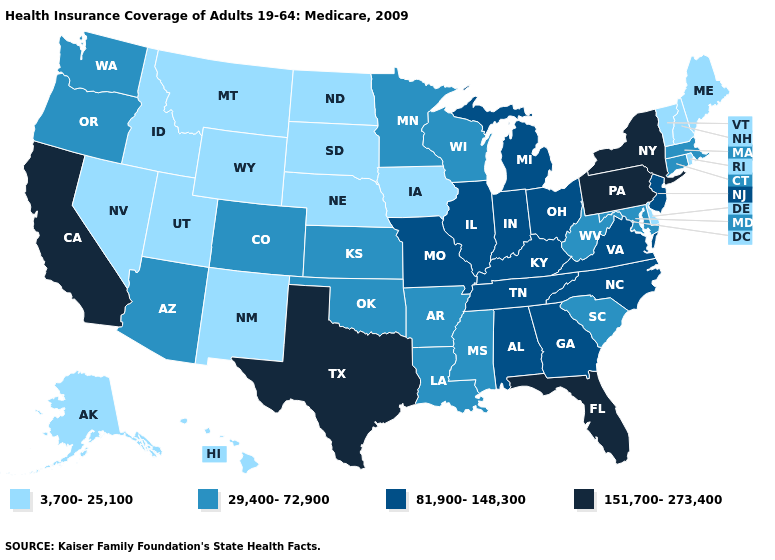Does Washington have the same value as Oklahoma?
Concise answer only. Yes. Does California have the lowest value in the USA?
Keep it brief. No. What is the value of Kansas?
Concise answer only. 29,400-72,900. Which states have the lowest value in the West?
Be succinct. Alaska, Hawaii, Idaho, Montana, Nevada, New Mexico, Utah, Wyoming. What is the value of Oregon?
Keep it brief. 29,400-72,900. What is the value of Ohio?
Short answer required. 81,900-148,300. What is the value of New York?
Be succinct. 151,700-273,400. Among the states that border Mississippi , does Arkansas have the lowest value?
Concise answer only. Yes. Which states have the lowest value in the South?
Short answer required. Delaware. What is the value of Mississippi?
Answer briefly. 29,400-72,900. Name the states that have a value in the range 29,400-72,900?
Concise answer only. Arizona, Arkansas, Colorado, Connecticut, Kansas, Louisiana, Maryland, Massachusetts, Minnesota, Mississippi, Oklahoma, Oregon, South Carolina, Washington, West Virginia, Wisconsin. What is the value of Ohio?
Be succinct. 81,900-148,300. Name the states that have a value in the range 151,700-273,400?
Short answer required. California, Florida, New York, Pennsylvania, Texas. Does Florida have the lowest value in the USA?
Keep it brief. No. Which states hav the highest value in the West?
Be succinct. California. 